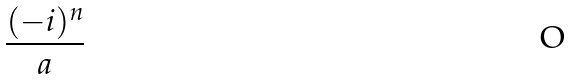Convert formula to latex. <formula><loc_0><loc_0><loc_500><loc_500>\frac { ( - i ) ^ { n } } { a }</formula> 